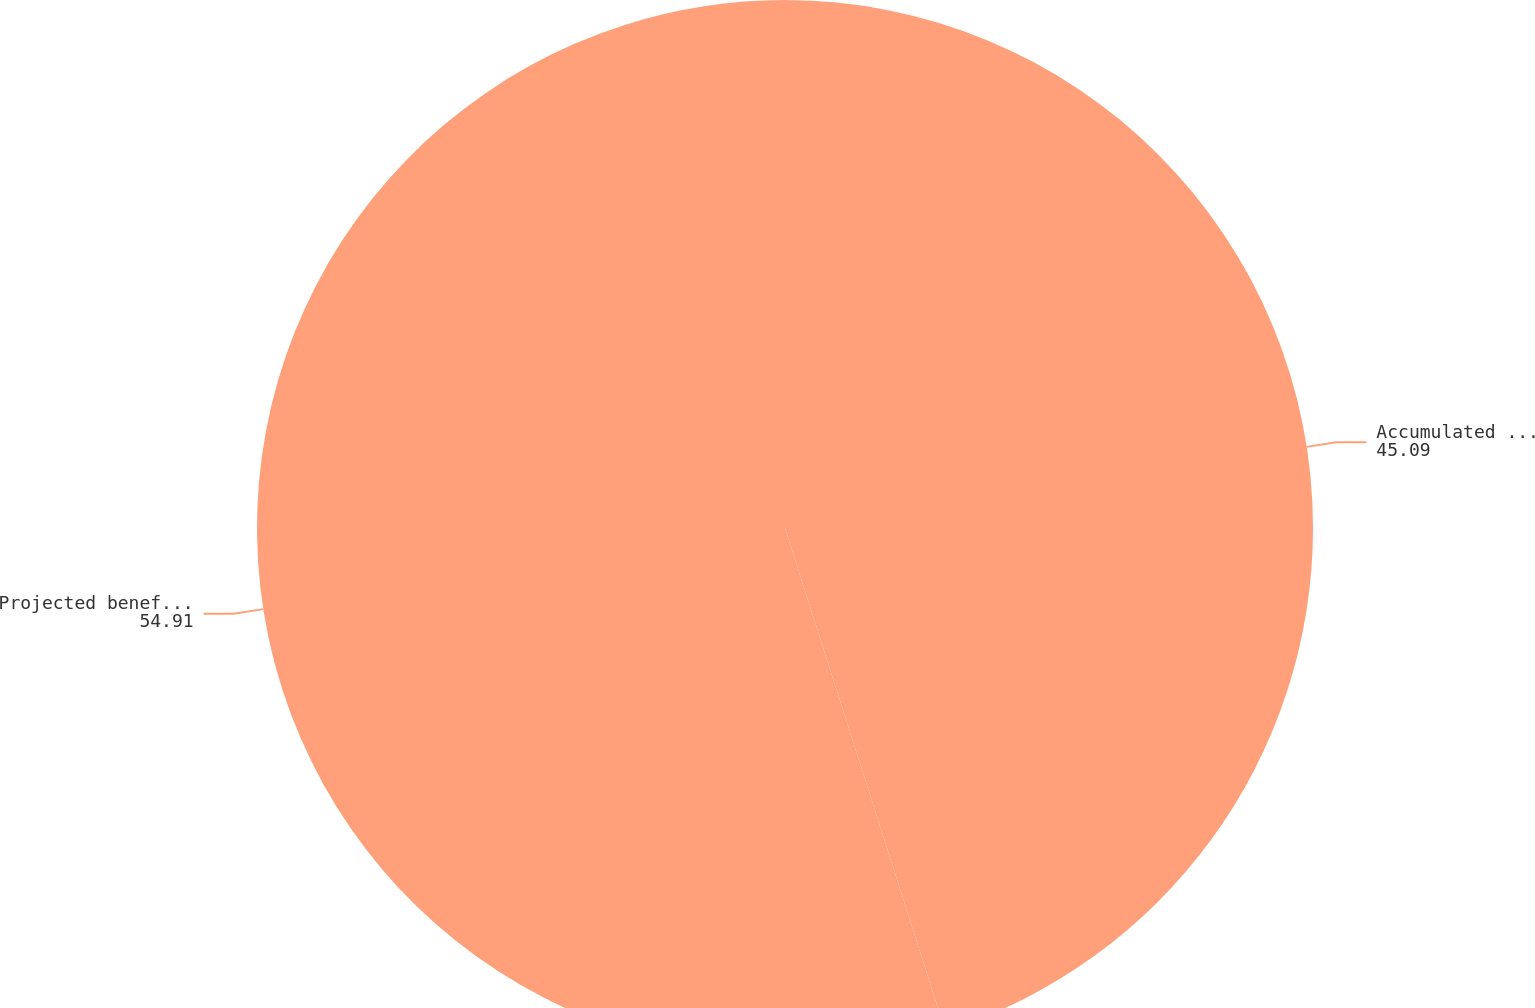<chart> <loc_0><loc_0><loc_500><loc_500><pie_chart><fcel>Accumulated benefit obligation<fcel>Projected benefit obligation<nl><fcel>45.09%<fcel>54.91%<nl></chart> 